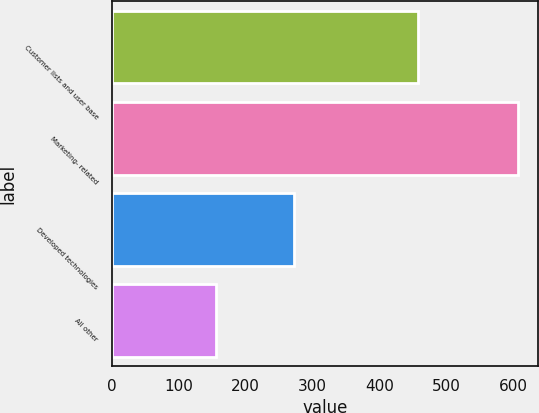<chart> <loc_0><loc_0><loc_500><loc_500><bar_chart><fcel>Customer lists and user base<fcel>Marketing- related<fcel>Developed technologies<fcel>All other<nl><fcel>458<fcel>607<fcel>273<fcel>156<nl></chart> 